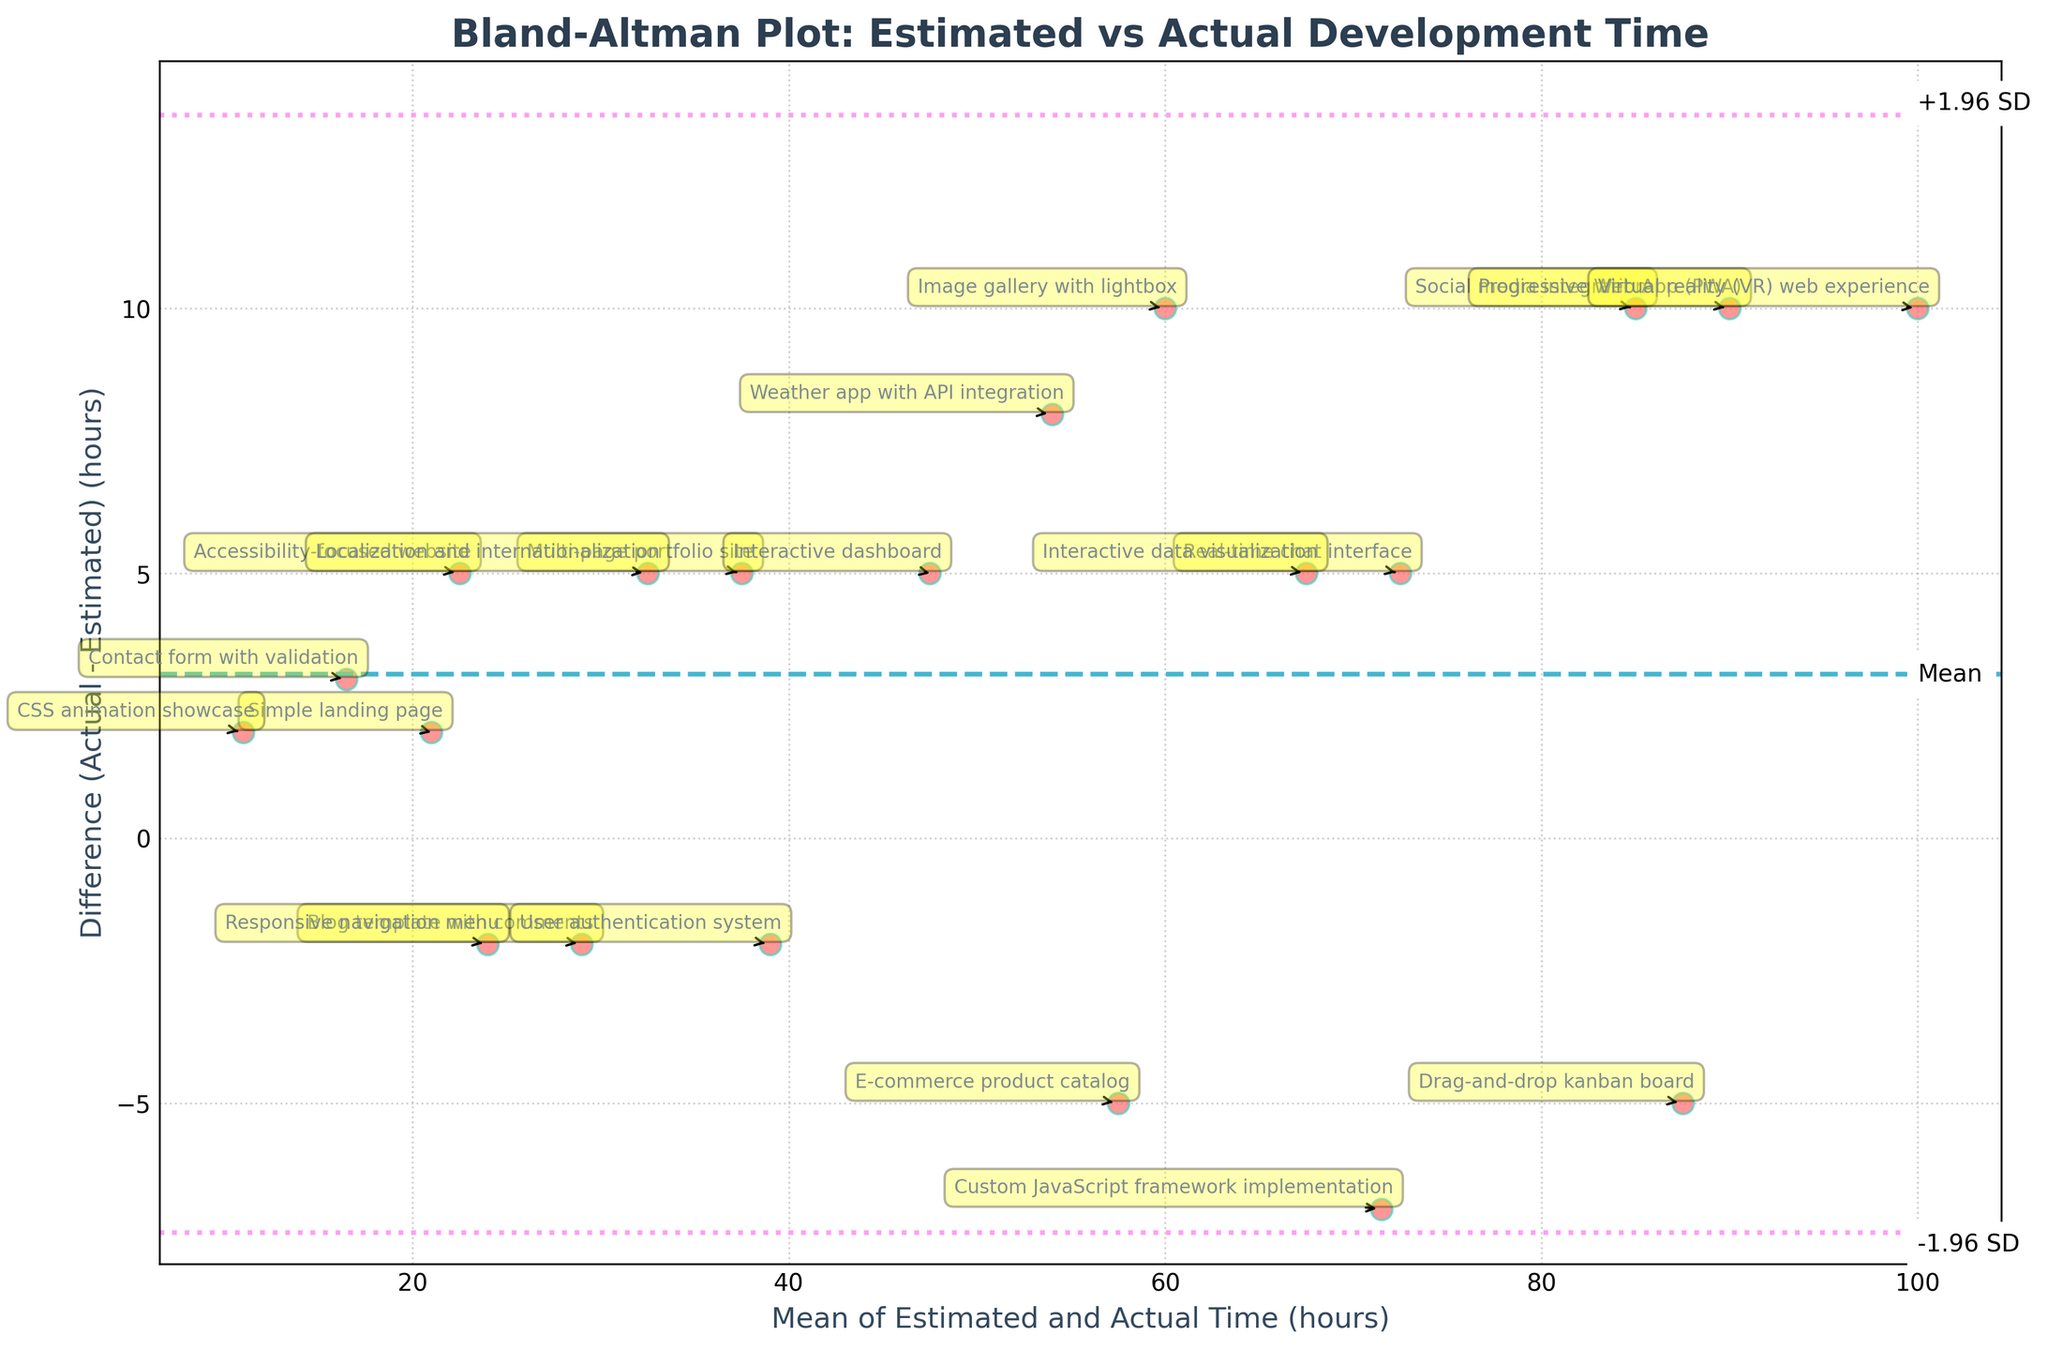what is the title of this plot? The title of the plot is displayed at the top of the chart. It provides a summary of what the chart is about, which in this case, is "Bland-Altman Plot: Estimated vs Actual Development Time".
Answer: Bland-Altman Plot: Estimated vs Actual Development Time What do the x-axis and y-axis represent in the plot? The x-axis represents the mean of estimated and actual time (in hours) for the development of front-end projects. The y-axis represents the difference (Actual - Estimated) in hours between the actual and estimated development times.
Answer: Mean of Estimated and Actual Time (hours), Difference (Actual - Estimated) (hours) How many data points are plotted in this Bland-Altman plot? Each project from the provided data is represented by a data point. Counting the number of projects listed in the data gives us the number of points on the plot. There are 20 projects listed, so there are 20 data points.
Answer: 20 What does the dashed horizontal line in the plot signify? The dashed horizontal line represents the mean difference between the actual and estimated development times. This line provides a reference to understand the average deviation of the estimates from the actual times.
Answer: Mean difference What is the significance of the dotted lines above and below the mean difference line? The dotted lines represent the limits of agreement, which are calculated as the mean difference ± 1.96 times the standard deviation of the differences. These lines help in understanding the range within which most differences between the estimated and actual times fall.
Answer: Limits of agreement How can you identify the project with the highest discrepancy between estimated and actual development time on this plot? The project with the highest discrepancy will have the point furthest from the horizontal mean difference line, in terms of vertical distance. From visual inspection, the 'Virtual reality (VR) web experience' project appears to have the highest discrepancy.
Answer: Virtual reality (VR) web experience What does it mean if a data point is below the mean difference line? If a data point is below the mean difference line, it means the estimated time was greater than the actual time, indicating that the project was completed faster than estimated.
Answer: Estimated time > Actual time Are there more projects where actual development time exceeded the estimated time or vice versa? By observing the distribution of points above and below the mean difference line, we can determine if there are more projects where the actual time exceeded the estimated time. There are more points above the mean difference line, indicating that for more projects, the actual time was higher than the estimated time.
Answer: Actual time > Estimated time Which project has the smallest discrepancy between estimated and actual development time and what is its complexity? The project with the smallest discrepancy will be the one closest to the mean difference line. 'User authentication system' appears to be the project with the smallest discrepancy. Its complexity is "User authentication system".
Answer: User authentication system What is the interpretation if most data points lie within the limits of agreement? If most data points lie within the limits of agreement, it indicates that the estimated development times are generally in close agreement with the actual development times for the majority of projects, within a range considered acceptable.
Answer: Close agreement 